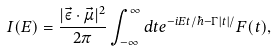<formula> <loc_0><loc_0><loc_500><loc_500>I ( E ) = \frac { | \vec { \varepsilon } \cdot \vec { \mu } | ^ { 2 } } { 2 \pi } \int _ { - \infty } ^ { \infty } d t e ^ { - i E t / \hbar { - } \Gamma | t | / } F ( t ) ,</formula> 